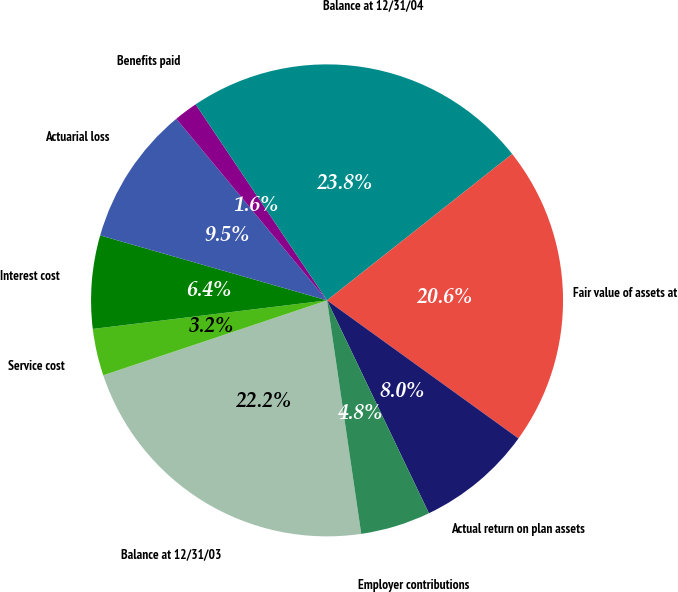Convert chart. <chart><loc_0><loc_0><loc_500><loc_500><pie_chart><fcel>Balance at 12/31/03<fcel>Service cost<fcel>Interest cost<fcel>Actuarial loss<fcel>Benefits paid<fcel>Balance at 12/31/04<fcel>Fair value of assets at<fcel>Actual return on plan assets<fcel>Employer contributions<nl><fcel>22.17%<fcel>3.21%<fcel>6.37%<fcel>9.53%<fcel>1.63%<fcel>23.75%<fcel>20.59%<fcel>7.95%<fcel>4.79%<nl></chart> 